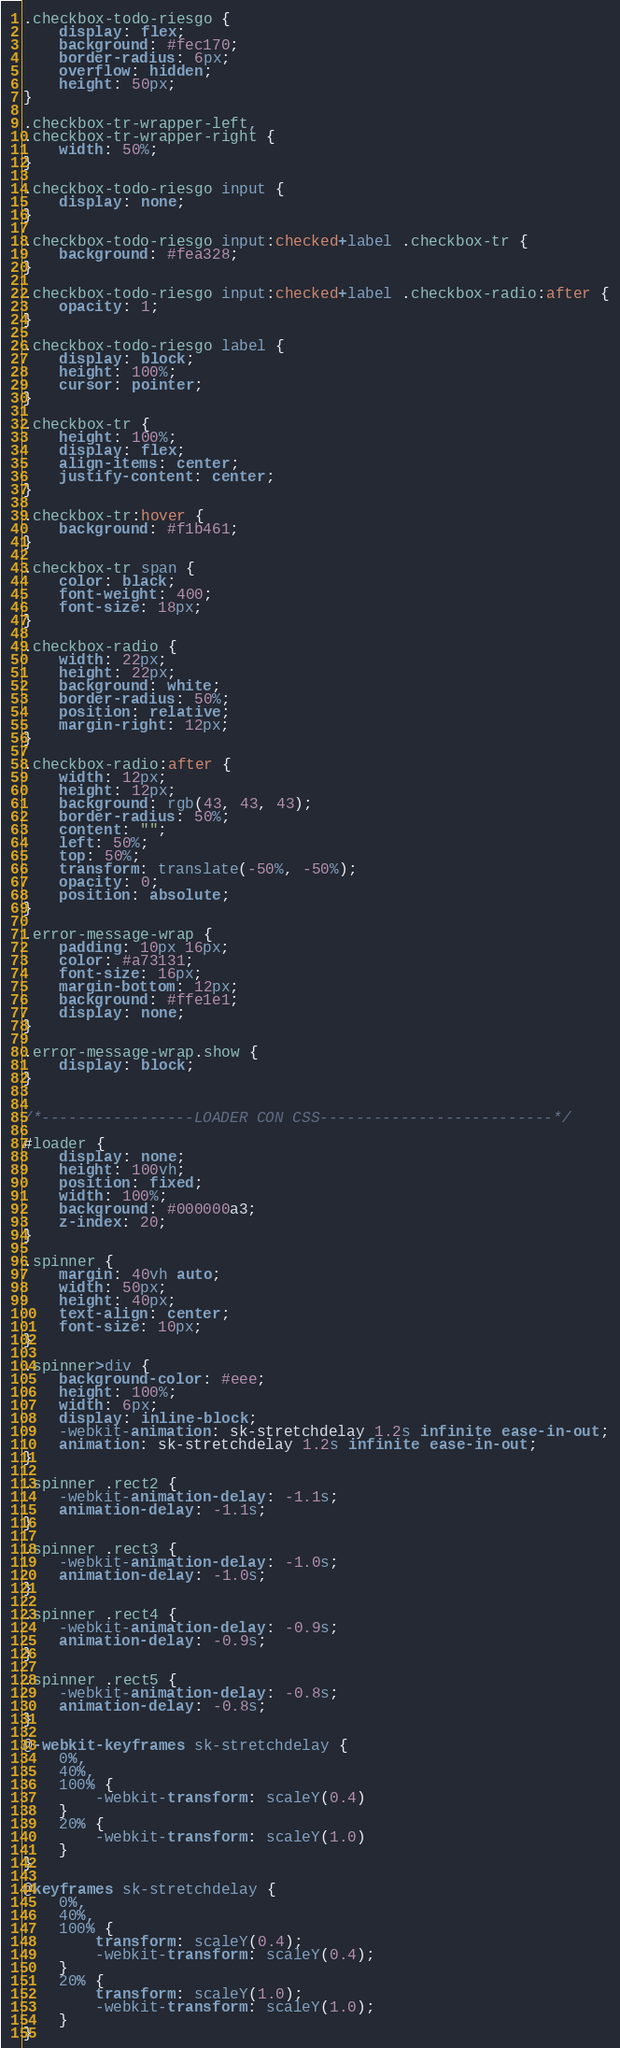<code> <loc_0><loc_0><loc_500><loc_500><_CSS_>.checkbox-todo-riesgo {
    display: flex;
    background: #fec170;
    border-radius: 6px;
    overflow: hidden;
    height: 50px;
}

.checkbox-tr-wrapper-left,
.checkbox-tr-wrapper-right {
    width: 50%;
}

.checkbox-todo-riesgo input {
    display: none;
}

.checkbox-todo-riesgo input:checked+label .checkbox-tr {
    background: #fea328;
}

.checkbox-todo-riesgo input:checked+label .checkbox-radio:after {
    opacity: 1;
}

.checkbox-todo-riesgo label {
    display: block;
    height: 100%;
    cursor: pointer;
}

.checkbox-tr {
    height: 100%;
    display: flex;
    align-items: center;
    justify-content: center;
}

.checkbox-tr:hover {
    background: #f1b461;
}

.checkbox-tr span {
    color: black;
    font-weight: 400;
    font-size: 18px;
}

.checkbox-radio {
    width: 22px;
    height: 22px;
    background: white;
    border-radius: 50%;
    position: relative;
    margin-right: 12px;
}

.checkbox-radio:after {
    width: 12px;
    height: 12px;
    background: rgb(43, 43, 43);
    border-radius: 50%;
    content: "";
    left: 50%;
    top: 50%;
    transform: translate(-50%, -50%);
    opacity: 0;
    position: absolute;
}

.error-message-wrap {
    padding: 10px 16px;
    color: #a73131;
    font-size: 16px;
    margin-bottom: 12px;
    background: #ffe1e1;
    display: none;
}

.error-message-wrap.show {
    display: block;
}


/*-----------------LOADER CON CSS--------------------------*/

#loader {
    display: none;
    height: 100vh;
    position: fixed;
    width: 100%;
    background: #000000a3;
    z-index: 20;
}

.spinner {
    margin: 40vh auto;
    width: 50px;
    height: 40px;
    text-align: center;
    font-size: 10px;
}

.spinner>div {
    background-color: #eee;
    height: 100%;
    width: 6px;
    display: inline-block;
    -webkit-animation: sk-stretchdelay 1.2s infinite ease-in-out;
    animation: sk-stretchdelay 1.2s infinite ease-in-out;
}

.spinner .rect2 {
    -webkit-animation-delay: -1.1s;
    animation-delay: -1.1s;
}

.spinner .rect3 {
    -webkit-animation-delay: -1.0s;
    animation-delay: -1.0s;
}

.spinner .rect4 {
    -webkit-animation-delay: -0.9s;
    animation-delay: -0.9s;
}

.spinner .rect5 {
    -webkit-animation-delay: -0.8s;
    animation-delay: -0.8s;
}

@-webkit-keyframes sk-stretchdelay {
    0%,
    40%,
    100% {
        -webkit-transform: scaleY(0.4)
    }
    20% {
        -webkit-transform: scaleY(1.0)
    }
}

@keyframes sk-stretchdelay {
    0%,
    40%,
    100% {
        transform: scaleY(0.4);
        -webkit-transform: scaleY(0.4);
    }
    20% {
        transform: scaleY(1.0);
        -webkit-transform: scaleY(1.0);
    }
}</code> 